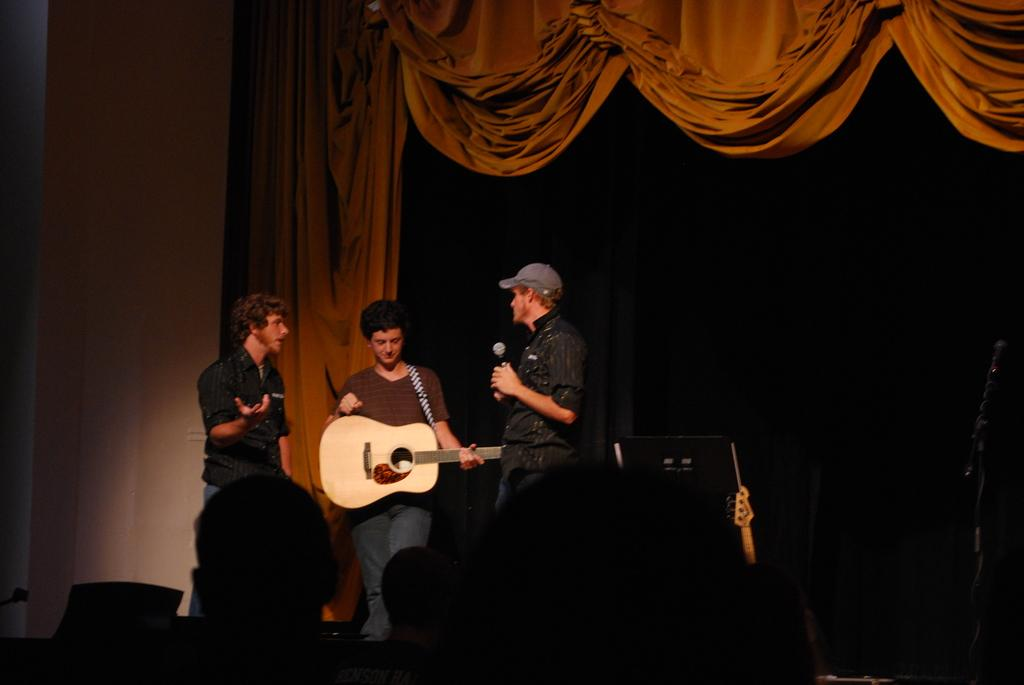What type of structure can be seen in the image? There is a wall in the image. What is hanging near the wall? There is a curtain in the image. What is happening in the image? There are three people standing on stage. What is one of the people holding? One of the people is holding a guitar. What is the taste of the building in the image? There is no building present in the image, and therefore no taste can be associated with it. 